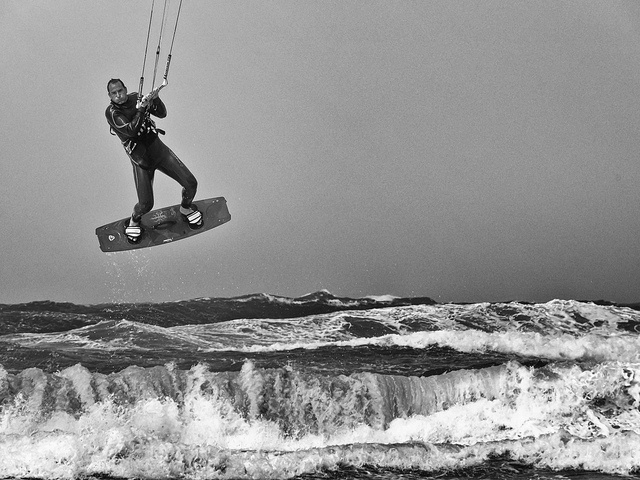Describe the objects in this image and their specific colors. I can see people in darkgray, black, gray, and lightgray tones and surfboard in darkgray, gray, black, and lightgray tones in this image. 